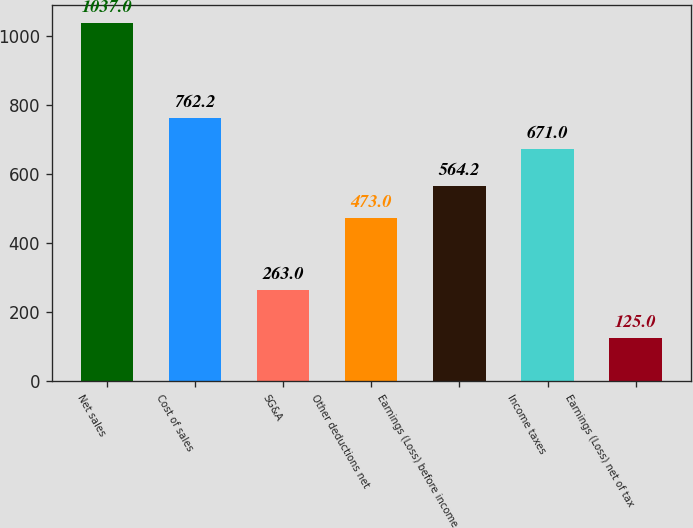Convert chart. <chart><loc_0><loc_0><loc_500><loc_500><bar_chart><fcel>Net sales<fcel>Cost of sales<fcel>SG&A<fcel>Other deductions net<fcel>Earnings (Loss) before income<fcel>Income taxes<fcel>Earnings (Loss) net of tax<nl><fcel>1037<fcel>762.2<fcel>263<fcel>473<fcel>564.2<fcel>671<fcel>125<nl></chart> 